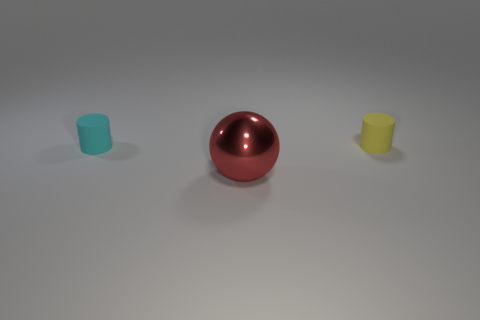Add 3 small gray metallic cylinders. How many objects exist? 6 Subtract all cylinders. How many objects are left? 1 Subtract 1 cyan cylinders. How many objects are left? 2 Subtract all cylinders. Subtract all tiny green cylinders. How many objects are left? 1 Add 3 tiny cyan cylinders. How many tiny cyan cylinders are left? 4 Add 1 rubber cylinders. How many rubber cylinders exist? 3 